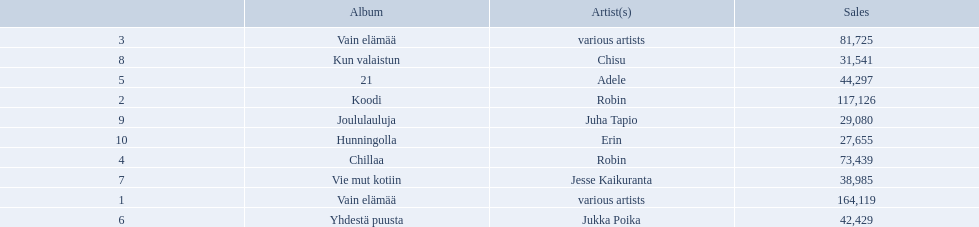What sales does adele have? 44,297. Could you parse the entire table as a dict? {'header': ['', 'Album', 'Artist(s)', 'Sales'], 'rows': [['3', 'Vain elämää', 'various artists', '81,725'], ['8', 'Kun valaistun', 'Chisu', '31,541'], ['5', '21', 'Adele', '44,297'], ['2', 'Koodi', 'Robin', '117,126'], ['9', 'Joululauluja', 'Juha Tapio', '29,080'], ['10', 'Hunningolla', 'Erin', '27,655'], ['4', 'Chillaa', 'Robin', '73,439'], ['7', 'Vie mut kotiin', 'Jesse Kaikuranta', '38,985'], ['1', 'Vain elämää', 'various artists', '164,119'], ['6', 'Yhdestä puusta', 'Jukka Poika', '42,429']]} What sales does chisu have? 31,541. Which of these numbers are higher? 44,297. Who has this number of sales? Adele. 